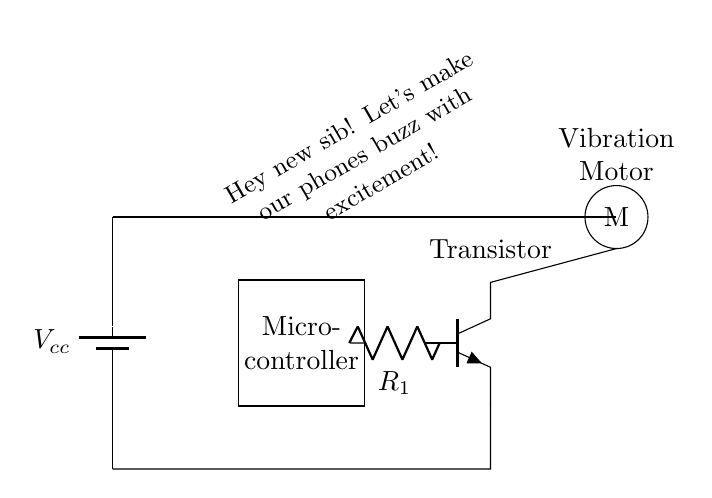What is the main purpose of this circuit? The main purpose of this circuit is to create custom phone alerts by using a vibration motor. The microcontroller is used to control when the motor operates.
Answer: Custom phone alerts What type of motor is used in this circuit? The type of motor used in this circuit is indicated by the "M" label, which stands for a vibration motor. This type of motor creates vibrations for alerts.
Answer: Vibration motor How many components are directly connected to the battery? There are three components directly connected to the battery: the microcontroller, the transistor, and the vibration motor, forming a complete circuit.
Answer: Three What role does the transistor play in this circuit? The transistor acts as a switch to control the current flowing to the vibration motor based on signals from the microcontroller. When activated, it allows current to flow to the motor.
Answer: Switch Which component is responsible for controlling the vibration motor? The microcontroller is responsible for controlling the vibration motor by sending signals to the transistor, which then allows or prevents current flow.
Answer: Microcontroller What is the value of the resistor labeled R1? The value of the resistor labeled R1 is not specified in the circuit diagram, but it's typically chosen based on the desired current through the transistor to protect it and the motor from exceeding safe limits.
Answer: Not specified What is the power source voltage in this circuit? The power source voltage is labeled as V sub cc, which suggests it's the supply voltage for the circuit; however, the specific value is not indicated in the diagram.
Answer: Not specified 